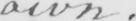Can you read and transcribe this handwriting? own . 